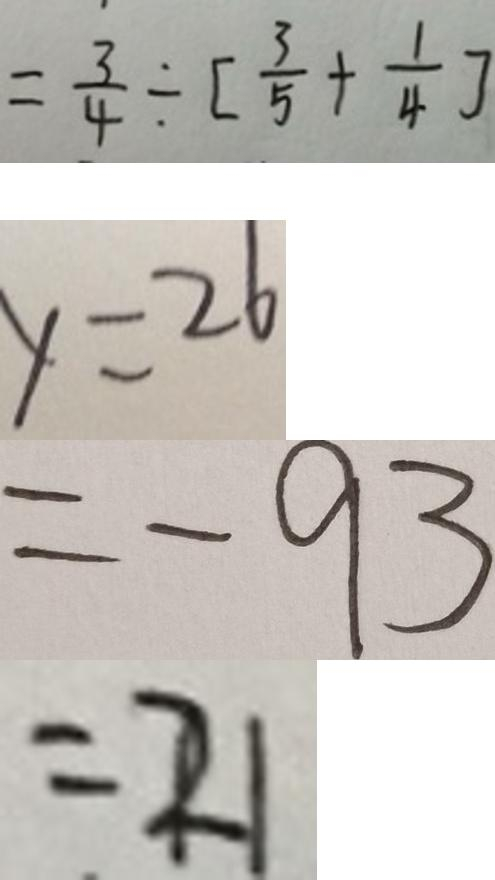Convert formula to latex. <formula><loc_0><loc_0><loc_500><loc_500>= \frac { 3 } { 4 } \div [ \frac { 3 } { 5 } + \frac { 1 } { 4 } ] 
 y = 2 6 
 = - 9 3 
 = 2 1</formula> 